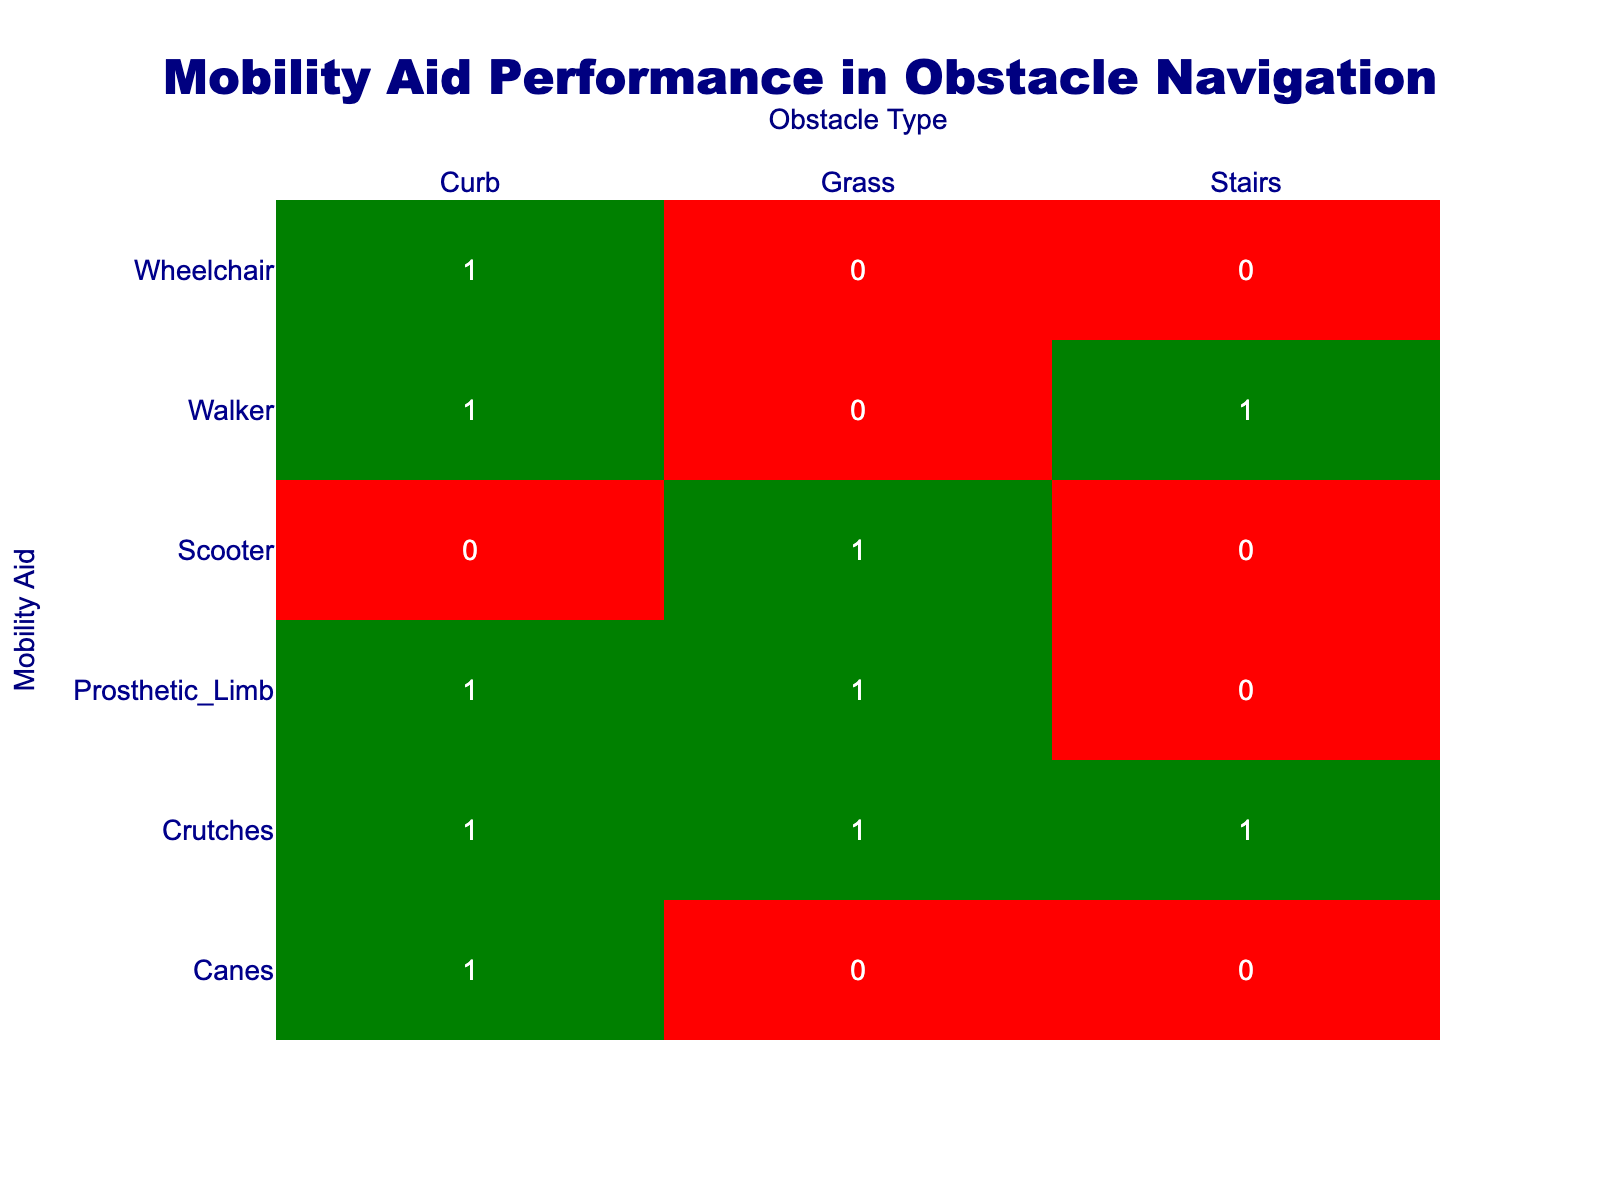What is the success rate of the Walker on Grass? The table shows that the Walker has a success value of 0 for Grass, indicating that it did not navigate the obstacle successfully. Therefore, the success rate for the Walker on Grass is 0%.
Answer: 0% Which mobility aid had the highest success rate at navigating the Curb? By looking at the table, we see that Wheelchair, Prosthetic Limb, Walker, Crutches, and Canes all have a success value of 1 for Curb. Since multiple aids have the same success rate, we can state that they all have the highest success rate of 100% on this obstacle.
Answer: Wheelchair, Prosthetic Limb, Walker, Crutches, Canes How many mobility aids succeeded on the Stairs? We can find the success values for each mobility aid on Stairs in the table. The only aids that succeeded are the Walker and Crutches, which have success values of 1. Therefore, there are two mobility aids that succeeded on Stairs.
Answer: 2 Did the Scooter succeed on any obstacles? Looking at the success values for the Scooter, it has a success value of 0 for both Curb and Stairs, and a success value of 1 for Grass. This means the Scooter only succeeded on Grass, so the answer is yes, it did succeed on one obstacle.
Answer: Yes Which mobility aid had the lowest total success across all obstacles? By summing the success values for each mobility aid from the table, we find: Wheelchair (1 + 0 + 0 = 1), Prosthetic Limb (1 + 1 + 0 = 2), Walker (1 + 0 + 1 = 2), Crutches (1 + 1 + 1 = 3), Scooter (0 + 1 + 0 = 1), Canes (1 + 0 + 0 = 1). The ones with the lowest total success (1) are Wheelchair, Scooter, and Canes.
Answer: Wheelchair, Scooter, Canes What is the total success count for Crutches in navigating all obstacles? We can refer to Crutches in the table: it has a success value of 1 for Curb, Grass, and Stairs. To find the total success count, we add these values: 1 (Curb) + 1 (Grass) + 1 (Stairs) = 3. Thus, the total is 3.
Answer: 3 